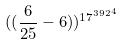<formula> <loc_0><loc_0><loc_500><loc_500>( ( \frac { 6 } { 2 5 } - 6 ) ) ^ { { 1 7 ^ { 3 9 2 } } ^ { 4 } }</formula> 